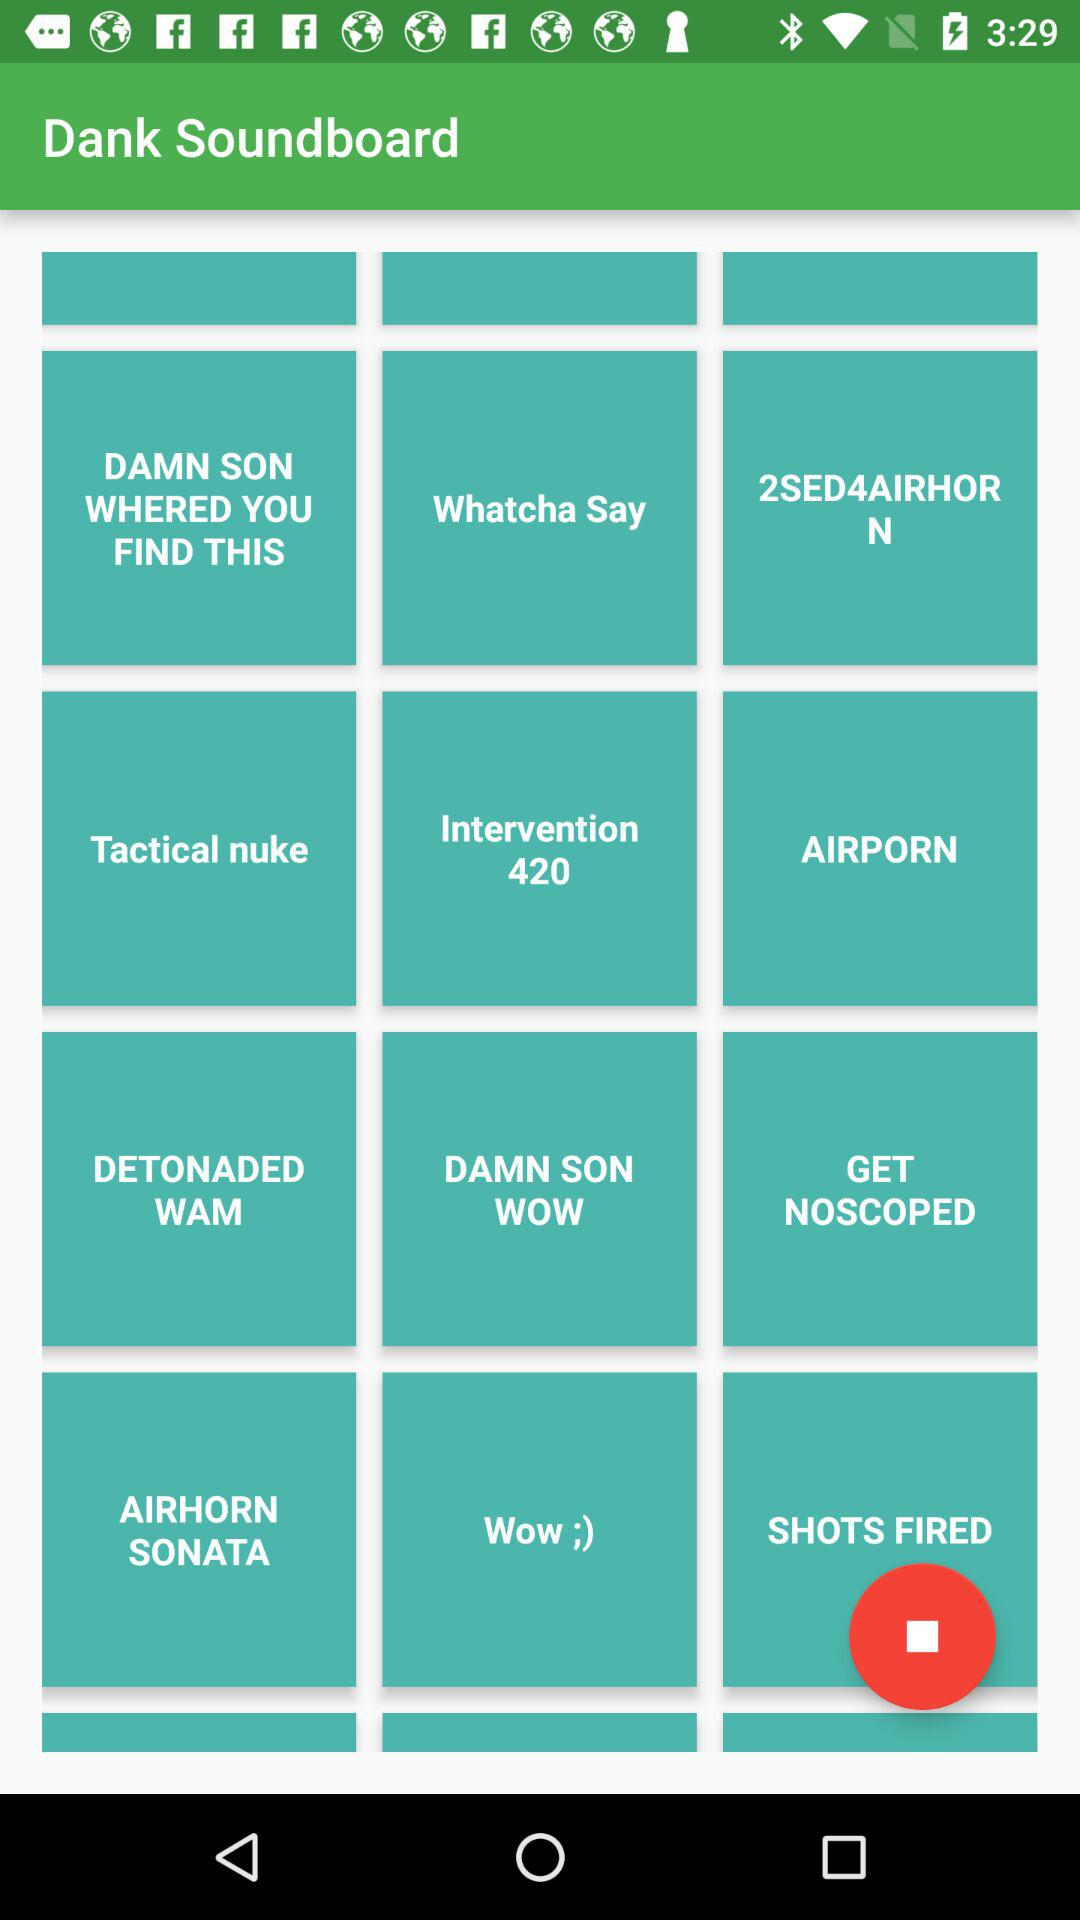Who is this application powered by?
When the provided information is insufficient, respond with <no answer>. <no answer> 